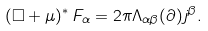<formula> <loc_0><loc_0><loc_500><loc_500>( \Box + \mu ) ^ { \ast } \, F _ { \alpha } = 2 \pi \Lambda _ { \alpha \beta } ( \partial ) j ^ { \beta } .</formula> 